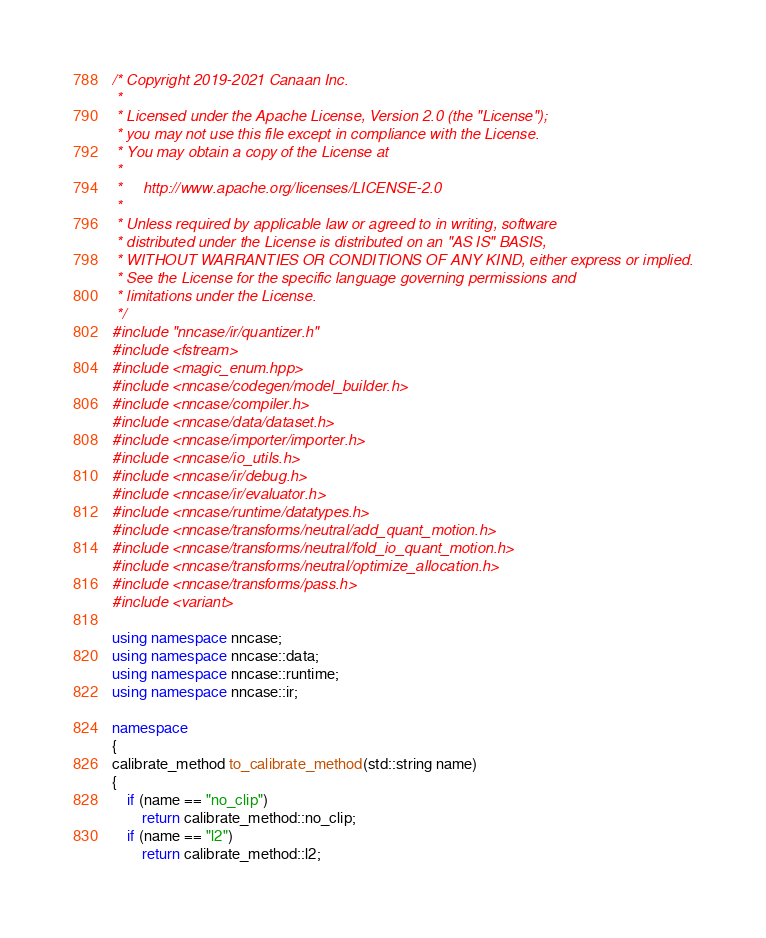<code> <loc_0><loc_0><loc_500><loc_500><_C++_>/* Copyright 2019-2021 Canaan Inc.
 *
 * Licensed under the Apache License, Version 2.0 (the "License");
 * you may not use this file except in compliance with the License.
 * You may obtain a copy of the License at
 *
 *     http://www.apache.org/licenses/LICENSE-2.0
 *
 * Unless required by applicable law or agreed to in writing, software
 * distributed under the License is distributed on an "AS IS" BASIS,
 * WITHOUT WARRANTIES OR CONDITIONS OF ANY KIND, either express or implied.
 * See the License for the specific language governing permissions and
 * limitations under the License.
 */
#include "nncase/ir/quantizer.h"
#include <fstream>
#include <magic_enum.hpp>
#include <nncase/codegen/model_builder.h>
#include <nncase/compiler.h>
#include <nncase/data/dataset.h>
#include <nncase/importer/importer.h>
#include <nncase/io_utils.h>
#include <nncase/ir/debug.h>
#include <nncase/ir/evaluator.h>
#include <nncase/runtime/datatypes.h>
#include <nncase/transforms/neutral/add_quant_motion.h>
#include <nncase/transforms/neutral/fold_io_quant_motion.h>
#include <nncase/transforms/neutral/optimize_allocation.h>
#include <nncase/transforms/pass.h>
#include <variant>

using namespace nncase;
using namespace nncase::data;
using namespace nncase::runtime;
using namespace nncase::ir;

namespace
{
calibrate_method to_calibrate_method(std::string name)
{
    if (name == "no_clip")
        return calibrate_method::no_clip;
    if (name == "l2")
        return calibrate_method::l2;</code> 